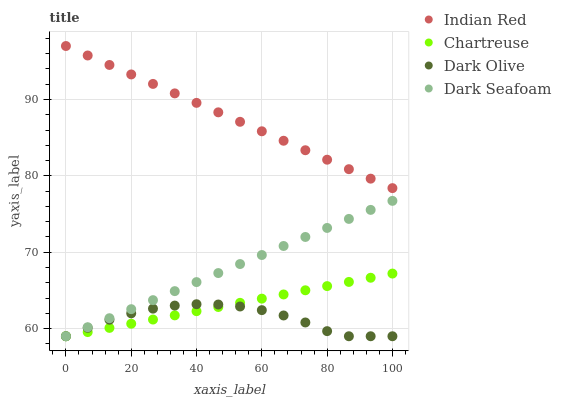Does Dark Olive have the minimum area under the curve?
Answer yes or no. Yes. Does Indian Red have the maximum area under the curve?
Answer yes or no. Yes. Does Dark Seafoam have the minimum area under the curve?
Answer yes or no. No. Does Dark Seafoam have the maximum area under the curve?
Answer yes or no. No. Is Chartreuse the smoothest?
Answer yes or no. Yes. Is Dark Olive the roughest?
Answer yes or no. Yes. Is Dark Seafoam the smoothest?
Answer yes or no. No. Is Dark Seafoam the roughest?
Answer yes or no. No. Does Chartreuse have the lowest value?
Answer yes or no. Yes. Does Indian Red have the lowest value?
Answer yes or no. No. Does Indian Red have the highest value?
Answer yes or no. Yes. Does Dark Seafoam have the highest value?
Answer yes or no. No. Is Dark Olive less than Indian Red?
Answer yes or no. Yes. Is Indian Red greater than Dark Olive?
Answer yes or no. Yes. Does Dark Seafoam intersect Chartreuse?
Answer yes or no. Yes. Is Dark Seafoam less than Chartreuse?
Answer yes or no. No. Is Dark Seafoam greater than Chartreuse?
Answer yes or no. No. Does Dark Olive intersect Indian Red?
Answer yes or no. No. 